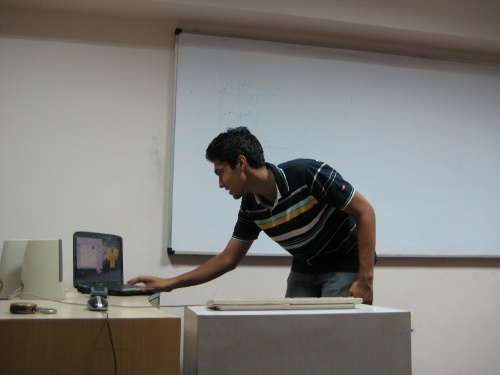Describe the objects in this image and their specific colors. I can see people in black, maroon, and gray tones, laptop in black, gray, and olive tones, mouse in black, gray, and darkgray tones, and mouse in black, darkgray, and gray tones in this image. 